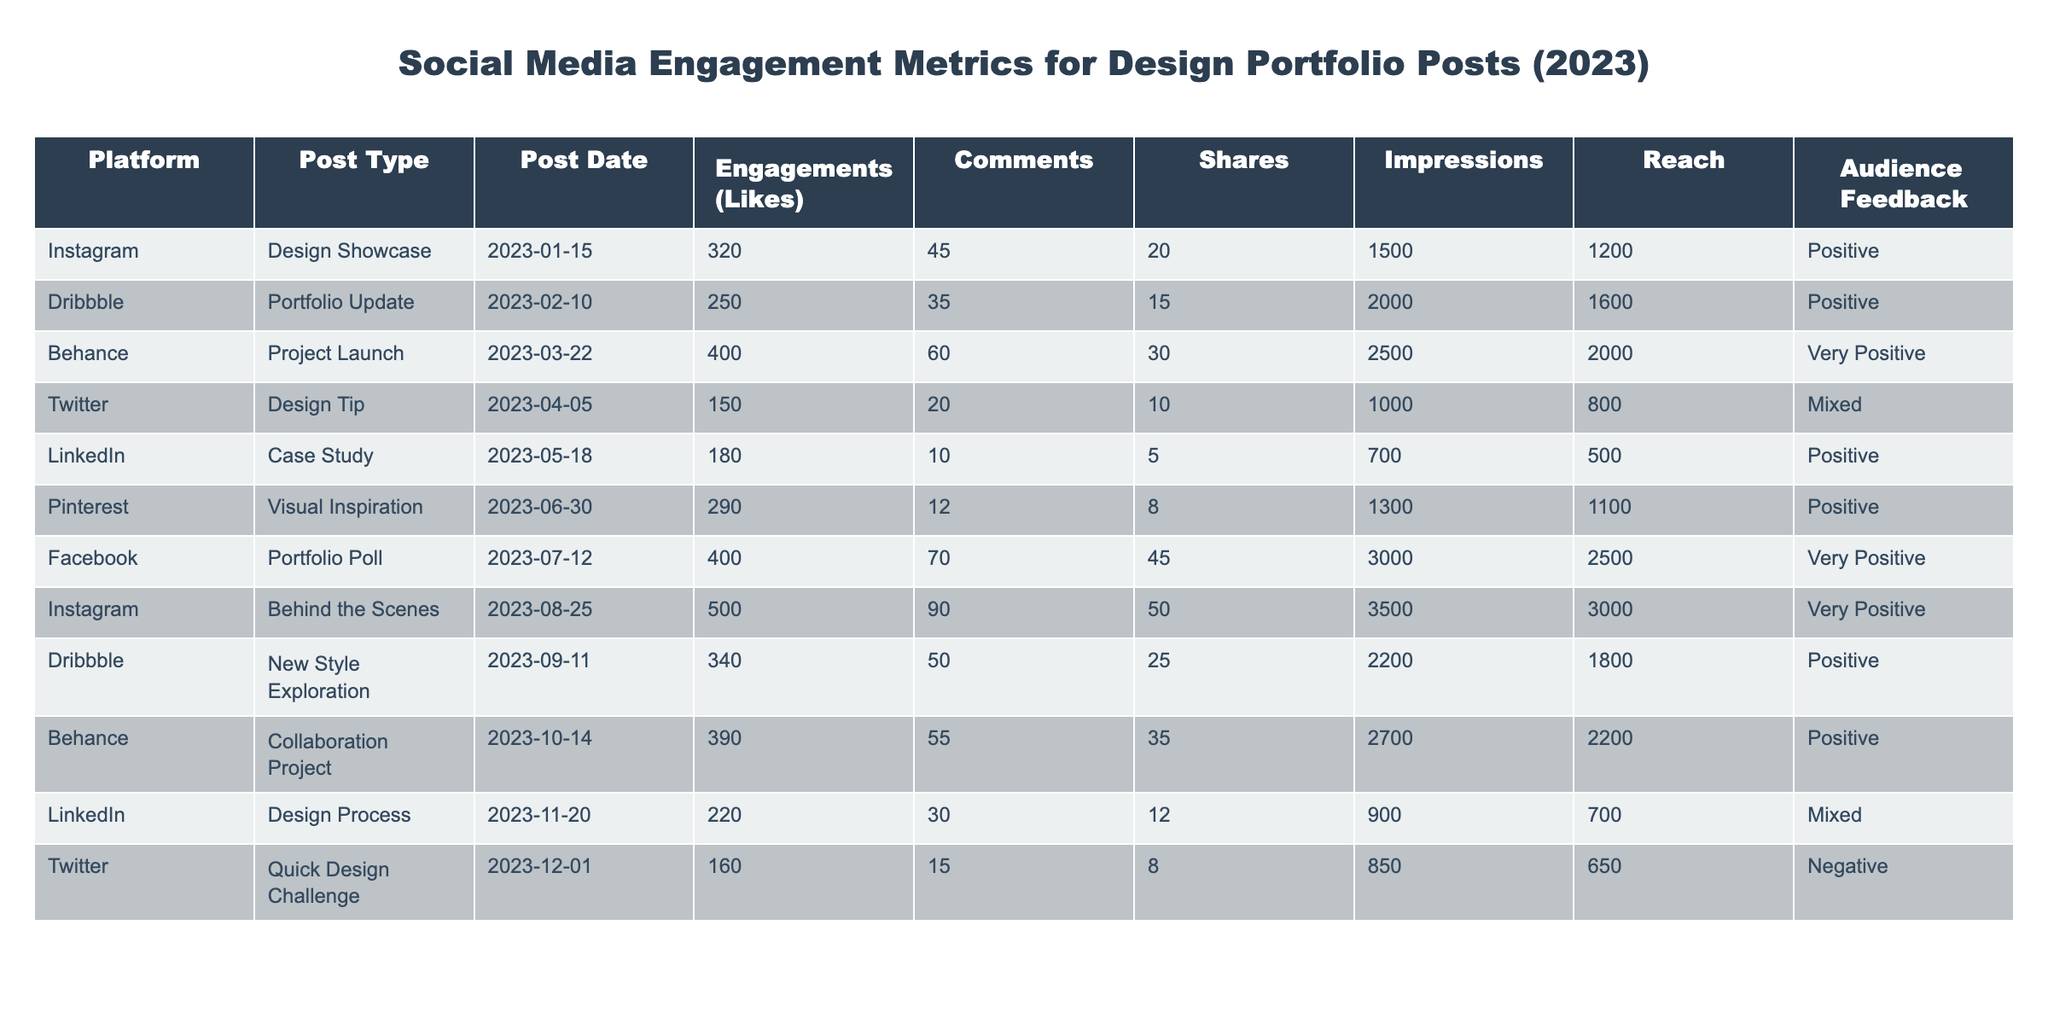What is the highest number of likes received on a single post? The highest number of likes in the table is found in the "Instagram, Behind the Scenes" post, which received 500 likes.
Answer: 500 Which platform had the most positive audience feedback? Both "Behance, Project Launch" and "Facebook, Portfolio Poll" received "Very Positive" feedback, but Behance had a higher engagement (400 engagements) compared to Facebook (400 engagements), making Behance the standout platform.
Answer: Behance How many shares did the "LinkedIn, Design Process" post receive? The table indicates that the "LinkedIn, Design Process" post received 12 shares.
Answer: 12 What is the average number of comments across all posts? To calculate the average, sum the comments: (45 + 35 + 60 + 20 + 10 + 12 + 70 + 90 + 50 + 55 + 30 + 15) = 400. There are 12 posts, so the average is 400/12 = 33.33, rounded to 33 for the answer.
Answer: 33 Is the audience feedback for the "Twitter, Quick Design Challenge" positive? The feedback for the "Twitter, Quick Design Challenge" is labeled as "Negative," which indicates it is not positive.
Answer: No What is the total number of engagements (likes + comments + shares) for the "Pinterest, Visual Inspiration" post? For "Pinterest, Visual Inspiration," the total engagements can be calculated by adding the likes (290), comments (12), and shares (8): 290 + 12 + 8 = 310.
Answer: 310 Which post type had the highest total reach across all platforms? By looking at the reach for each post (1200, 1600, 2000, 800, 500, 1100, 2500, 3000, 1800, 2200, 700, and 650), it can be observed that "Instagram, Behind the Scenes" had the highest reach of 3000.
Answer: Instagram, Behind the Scenes What is the difference in number of impressions between the post with the highest likes and the post with the lowest likes? The post with the highest likes is the "Instagram, Behind the Scenes" post with 3500 impressions and the post with the lowest likes is "Twitter, Quick Design Challenge" with 850 impressions. The difference is 3500 - 850 = 2650.
Answer: 2650 Which platform has the lowest number of engagements in a post? The lowest number of engagements is found in the "Twitter, Design Tip" post with a total of 150 engagements (likes + comments + shares).
Answer: Twitter, Design Tip 